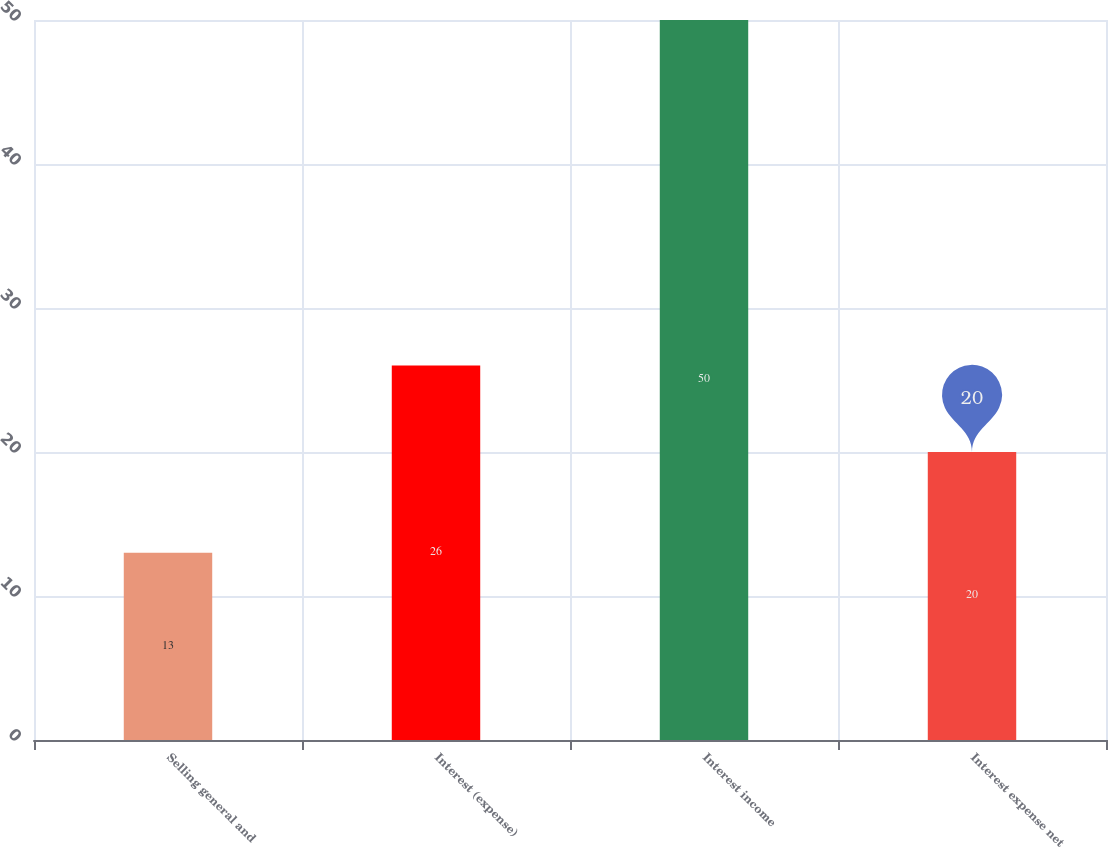Convert chart. <chart><loc_0><loc_0><loc_500><loc_500><bar_chart><fcel>Selling general and<fcel>Interest (expense)<fcel>Interest income<fcel>Interest expense net<nl><fcel>13<fcel>26<fcel>50<fcel>20<nl></chart> 